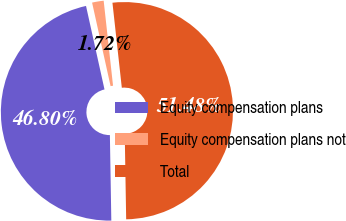Convert chart to OTSL. <chart><loc_0><loc_0><loc_500><loc_500><pie_chart><fcel>Equity compensation plans<fcel>Equity compensation plans not<fcel>Total<nl><fcel>46.8%<fcel>1.72%<fcel>51.48%<nl></chart> 